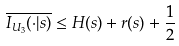Convert formula to latex. <formula><loc_0><loc_0><loc_500><loc_500>\overline { { { I _ { U _ { 3 } } ( \cdot | s ) } } } \leq H ( s ) + r ( s ) + \frac { 1 } { 2 }</formula> 